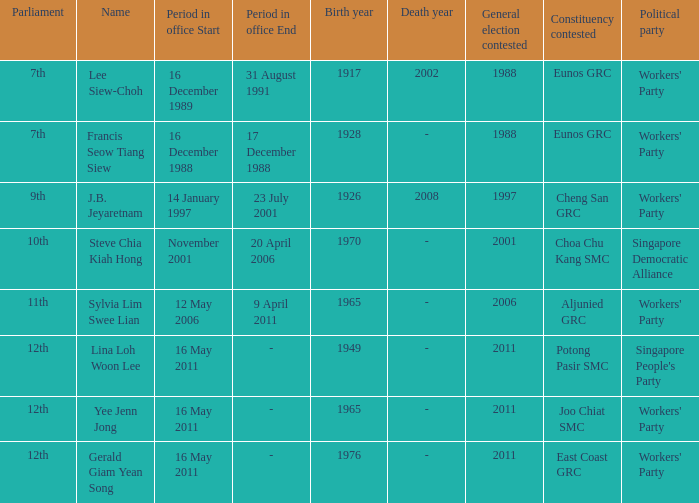Which parliamentary session held its election in the year 1997? 9th. 